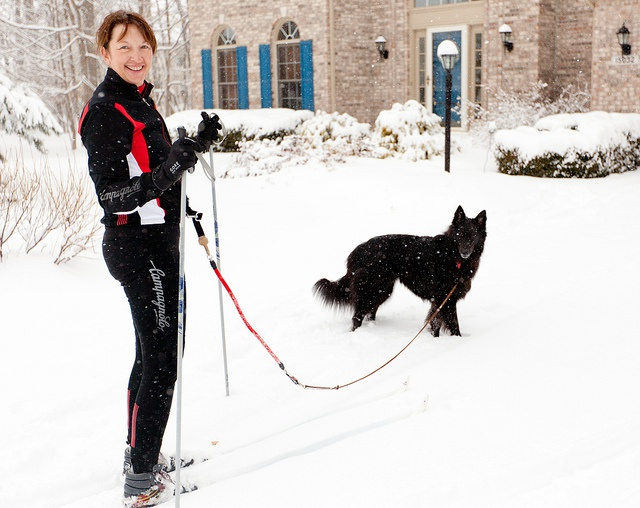Describe the objects in this image and their specific colors. I can see people in lightgray, black, gray, and tan tones, dog in lightgray, black, gray, and darkgray tones, and skis in lightgray, white, gray, darkgray, and tan tones in this image. 